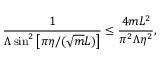<formula> <loc_0><loc_0><loc_500><loc_500>\frac { 1 } { \Lambda \sin ^ { 2 } \left [ \pi \eta / ( \sqrt { m } L ) \right ] } \leq \frac { 4 m L ^ { 2 } } { \pi ^ { 2 } \Lambda \eta ^ { 2 } } ,</formula> 